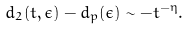<formula> <loc_0><loc_0><loc_500><loc_500>d _ { 2 } ( t , \epsilon ) - d _ { p } ( \epsilon ) \sim - t ^ { - \eta } .</formula> 